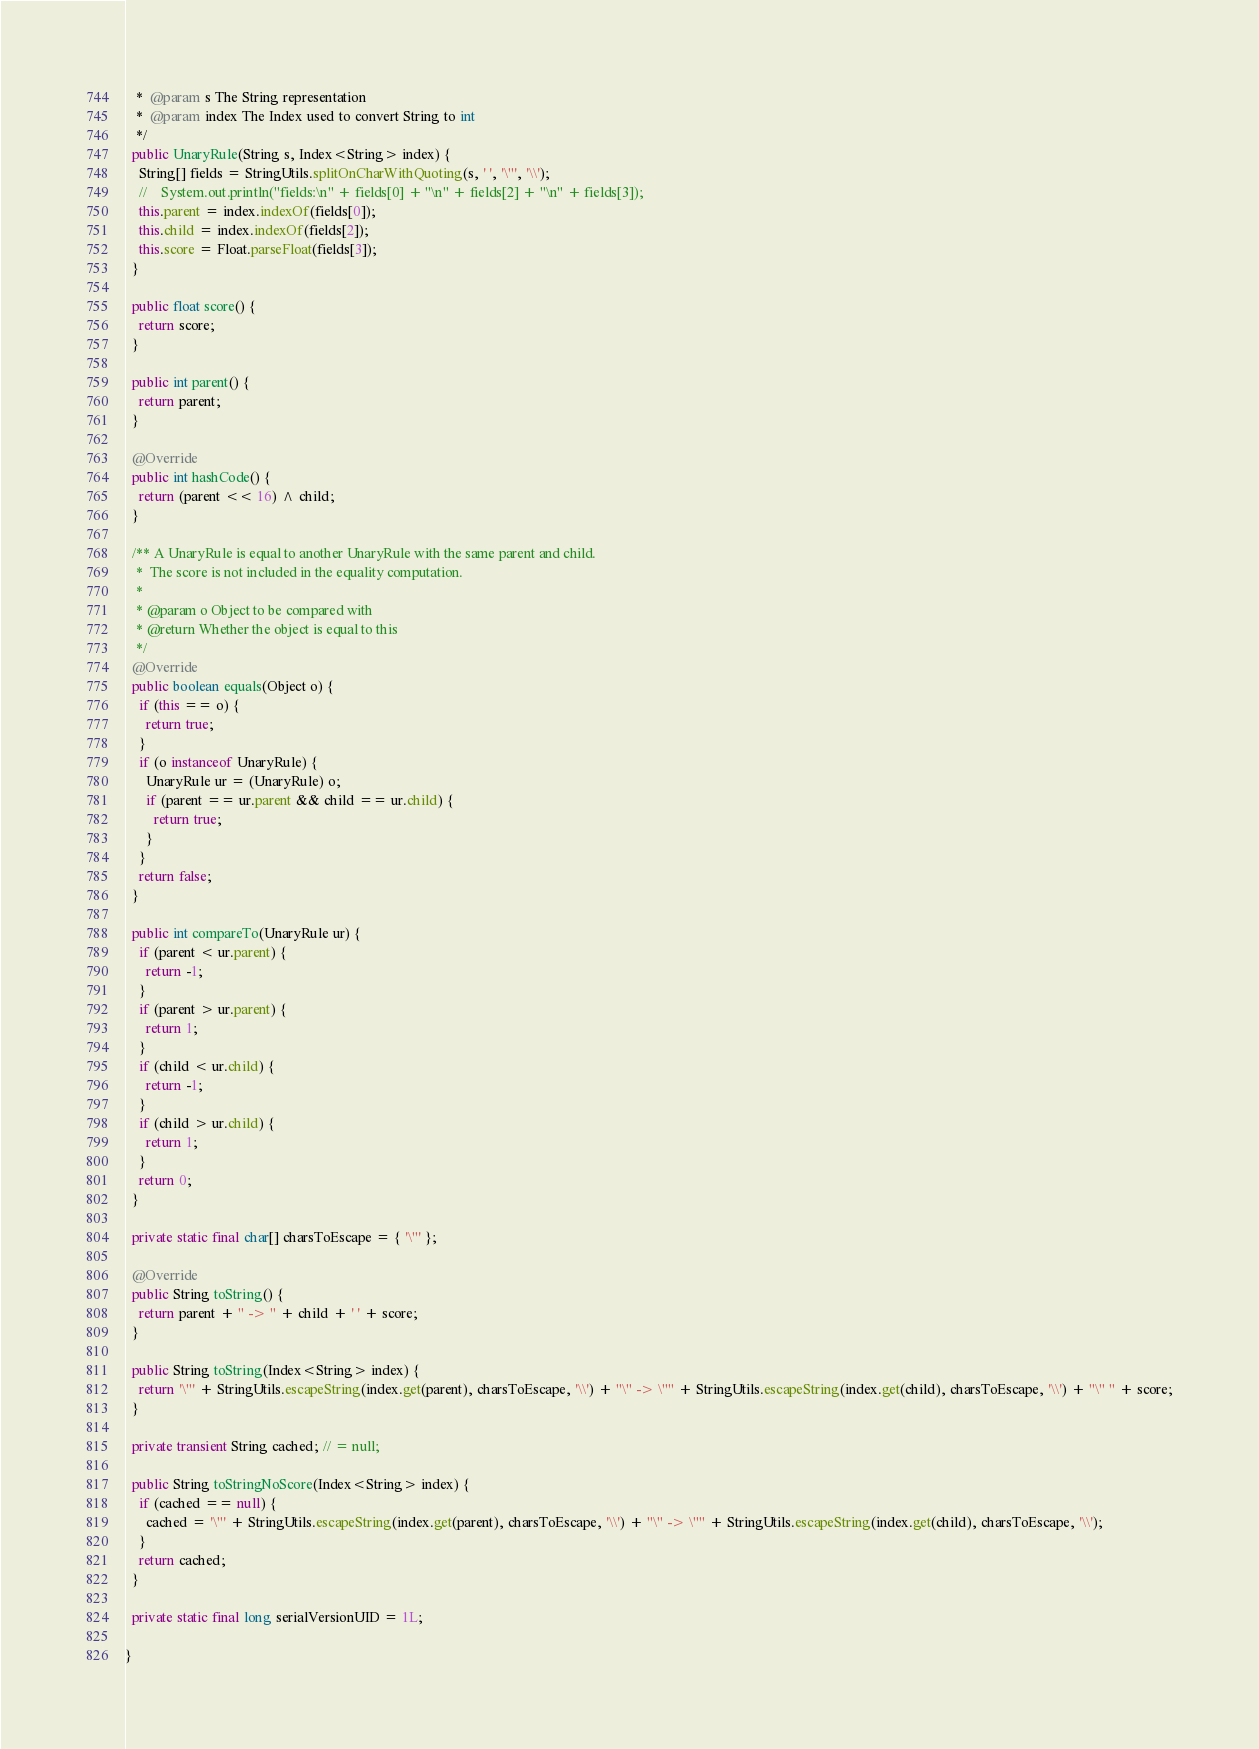<code> <loc_0><loc_0><loc_500><loc_500><_Java_>   *  @param s The String representation
   *  @param index The Index used to convert String to int
   */
  public UnaryRule(String s, Index<String> index) {
    String[] fields = StringUtils.splitOnCharWithQuoting(s, ' ', '\"', '\\');
    //    System.out.println("fields:\n" + fields[0] + "\n" + fields[2] + "\n" + fields[3]);
    this.parent = index.indexOf(fields[0]);
    this.child = index.indexOf(fields[2]);
    this.score = Float.parseFloat(fields[3]);
  }

  public float score() {
    return score;
  }

  public int parent() {
    return parent;
  }

  @Override
  public int hashCode() {
    return (parent << 16) ^ child;
  }

  /** A UnaryRule is equal to another UnaryRule with the same parent and child.
   *  The score is not included in the equality computation.
   *
   * @param o Object to be compared with
   * @return Whether the object is equal to this
   */
  @Override
  public boolean equals(Object o) {
    if (this == o) {
      return true;
    }
    if (o instanceof UnaryRule) {
      UnaryRule ur = (UnaryRule) o;
      if (parent == ur.parent && child == ur.child) {
        return true;
      }
    }
    return false;
  }

  public int compareTo(UnaryRule ur) {
    if (parent < ur.parent) {
      return -1;
    }
    if (parent > ur.parent) {
      return 1;
    }
    if (child < ur.child) {
      return -1;
    }
    if (child > ur.child) {
      return 1;
    }
    return 0;
  }

  private static final char[] charsToEscape = { '\"' };

  @Override
  public String toString() {
    return parent + " -> " + child + ' ' + score;
  }

  public String toString(Index<String> index) {
    return '\"' + StringUtils.escapeString(index.get(parent), charsToEscape, '\\') + "\" -> \"" + StringUtils.escapeString(index.get(child), charsToEscape, '\\') + "\" " + score;
  }

  private transient String cached; // = null;

  public String toStringNoScore(Index<String> index) {
    if (cached == null) {
      cached = '\"' + StringUtils.escapeString(index.get(parent), charsToEscape, '\\') + "\" -> \"" + StringUtils.escapeString(index.get(child), charsToEscape, '\\');
    }
    return cached;
  }

  private static final long serialVersionUID = 1L;

}

</code> 